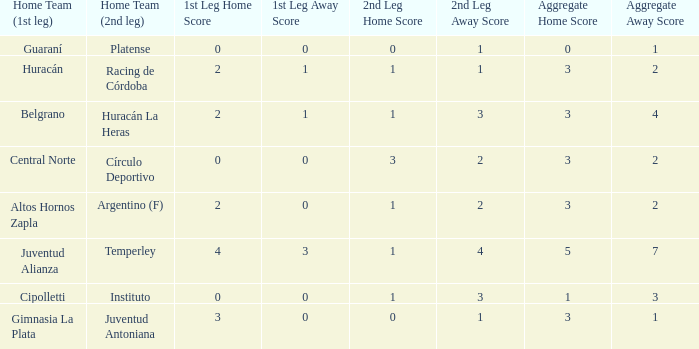What was the aggregate score that had a 1-2 second leg score? 3-2. 